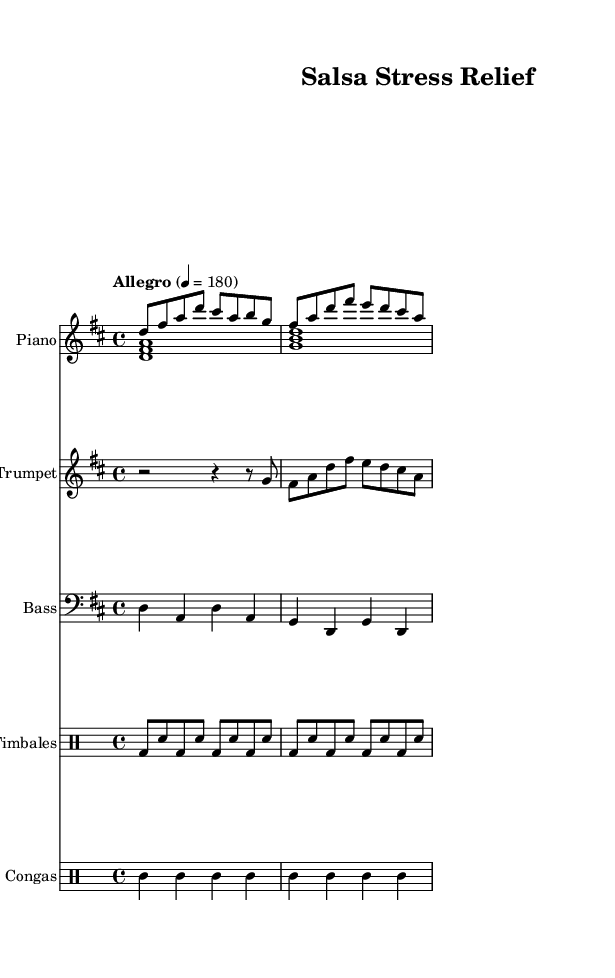What is the key signature of this music? The key signature is D major, which has two sharps (F# and C#).
Answer: D major What is the time signature of this piece? The time signature is 4/4, indicating four beats per measure and a quarter note receives one beat.
Answer: 4/4 What is the tempo marking for this music? The tempo marking is "Allegro," which indicates a fast and lively pace; additionally, it states the metronome marking is 180 beats per minute.
Answer: Allegro How many instruments are included in this score? There are five instruments listed: Piano, Trumpet, Bass, Timbales, and Congas.
Answer: Five Which instrument has a staff labeled as "pianoRH"? The staff labeled "pianoRH" is specifically for the right hand of the Piano.
Answer: Piano What type of rhythm notation is used for the Timbales? The rhythm notation for the Timbales is in a standard drum notation, using bass drum and snare notes, indicated by the letters bd and sn.
Answer: Drum notation What is the primary musical feature used in Salsa music as seen in this score? The primary feature is the syncopated rhythms from the congas and timbales, which create that characteristic Latin groove.
Answer: Syncopated rhythms 